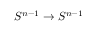<formula> <loc_0><loc_0><loc_500><loc_500>S ^ { n - 1 } \to S ^ { n - 1 }</formula> 